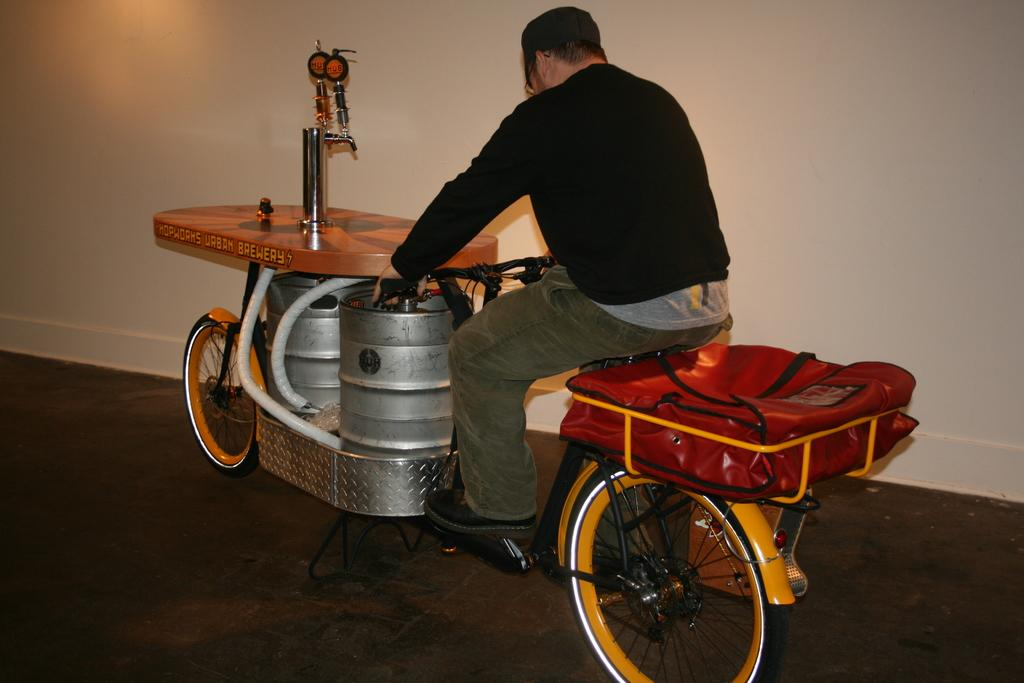What is the main subject of the image? The main subject of the image is a man. What is the man doing in the image? The man is riding a vehicle in the image. What color is the sweater the man is wearing? The man is wearing a black color sweater. What type of coil can be seen in the image? There is no coil present in the image. What kind of cart is being pulled by the man in the image? The man is riding a vehicle, not a cart, in the image. 